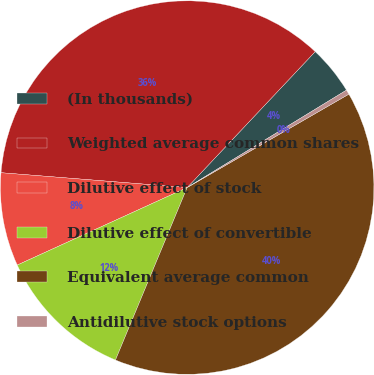Convert chart. <chart><loc_0><loc_0><loc_500><loc_500><pie_chart><fcel>(In thousands)<fcel>Weighted average common shares<fcel>Dilutive effect of stock<fcel>Dilutive effect of convertible<fcel>Equivalent average common<fcel>Antidilutive stock options<nl><fcel>4.24%<fcel>35.76%<fcel>8.08%<fcel>11.92%<fcel>39.61%<fcel>0.4%<nl></chart> 